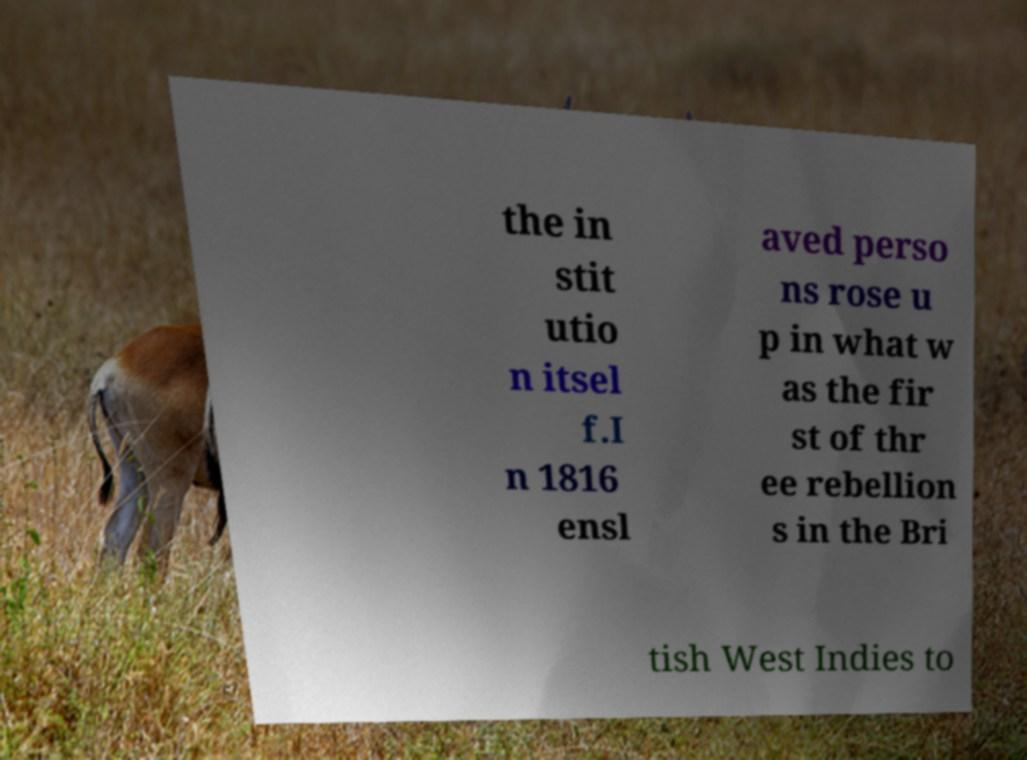Can you read and provide the text displayed in the image?This photo seems to have some interesting text. Can you extract and type it out for me? the in stit utio n itsel f.I n 1816 ensl aved perso ns rose u p in what w as the fir st of thr ee rebellion s in the Bri tish West Indies to 